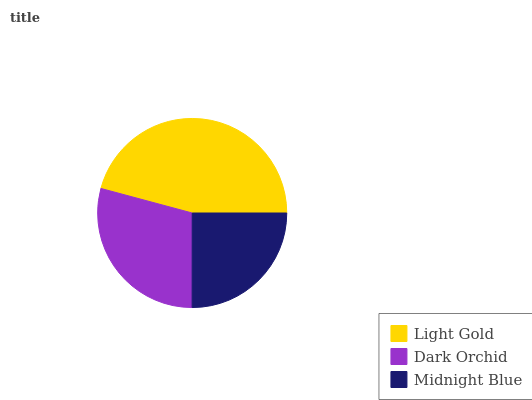Is Midnight Blue the minimum?
Answer yes or no. Yes. Is Light Gold the maximum?
Answer yes or no. Yes. Is Dark Orchid the minimum?
Answer yes or no. No. Is Dark Orchid the maximum?
Answer yes or no. No. Is Light Gold greater than Dark Orchid?
Answer yes or no. Yes. Is Dark Orchid less than Light Gold?
Answer yes or no. Yes. Is Dark Orchid greater than Light Gold?
Answer yes or no. No. Is Light Gold less than Dark Orchid?
Answer yes or no. No. Is Dark Orchid the high median?
Answer yes or no. Yes. Is Dark Orchid the low median?
Answer yes or no. Yes. Is Midnight Blue the high median?
Answer yes or no. No. Is Midnight Blue the low median?
Answer yes or no. No. 